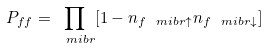<formula> <loc_0><loc_0><loc_500><loc_500>P _ { f f } = \prod _ { \ m i b { r } } [ 1 - n _ { f \ m i b { r } \uparrow } n _ { f \ m i b { r } \downarrow } ]</formula> 